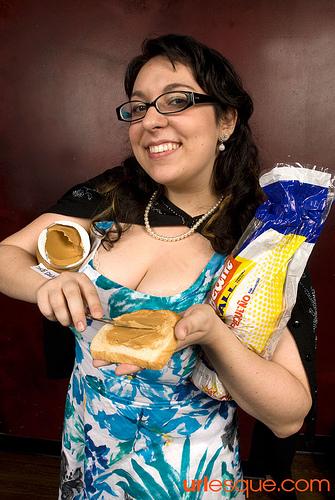Is this woman pretty?
Quick response, please. Yes. How many slices of pizza does this person have?
Keep it brief. 0. Does she want to sunbathe?
Give a very brief answer. No. Is this how someone generally makes a sandwich?
Answer briefly. No. What is the lady spreading on the bread?
Write a very short answer. Peanut butter. 